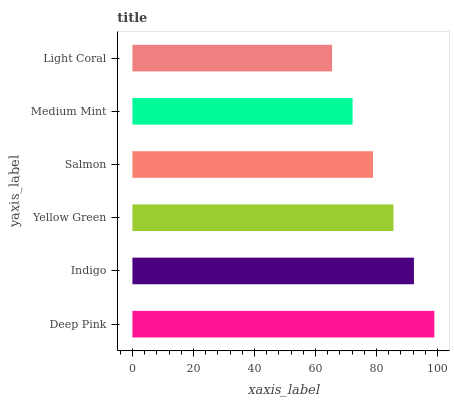Is Light Coral the minimum?
Answer yes or no. Yes. Is Deep Pink the maximum?
Answer yes or no. Yes. Is Indigo the minimum?
Answer yes or no. No. Is Indigo the maximum?
Answer yes or no. No. Is Deep Pink greater than Indigo?
Answer yes or no. Yes. Is Indigo less than Deep Pink?
Answer yes or no. Yes. Is Indigo greater than Deep Pink?
Answer yes or no. No. Is Deep Pink less than Indigo?
Answer yes or no. No. Is Yellow Green the high median?
Answer yes or no. Yes. Is Salmon the low median?
Answer yes or no. Yes. Is Deep Pink the high median?
Answer yes or no. No. Is Light Coral the low median?
Answer yes or no. No. 